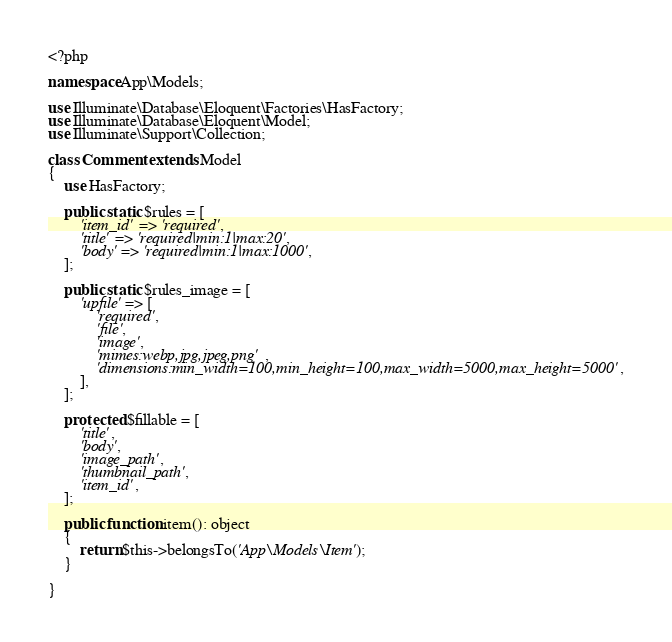<code> <loc_0><loc_0><loc_500><loc_500><_PHP_><?php

namespace App\Models;

use Illuminate\Database\Eloquent\Factories\HasFactory;
use Illuminate\Database\Eloquent\Model;
use Illuminate\Support\Collection;

class Comment extends Model
{
    use HasFactory;

    public static $rules = [
        'item_id' => 'required',
        'title' => 'required|min:1|max:20',
        'body' => 'required|min:1|max:1000',
    ];

    public static $rules_image = [
        'upfile' => [
            'required',
            'file',
            'image',
            'mimes:webp,jpg,jpeg,png',
            'dimensions:min_width=100,min_height=100,max_width=5000,max_height=5000',
        ],
    ];

    protected $fillable = [
        'title',
        'body',
        'image_path',
        'thumbnail_path',
        'item_id',
    ];

    public function item(): object
    {
        return $this->belongsTo('App\Models\Item');
    }

}
</code> 